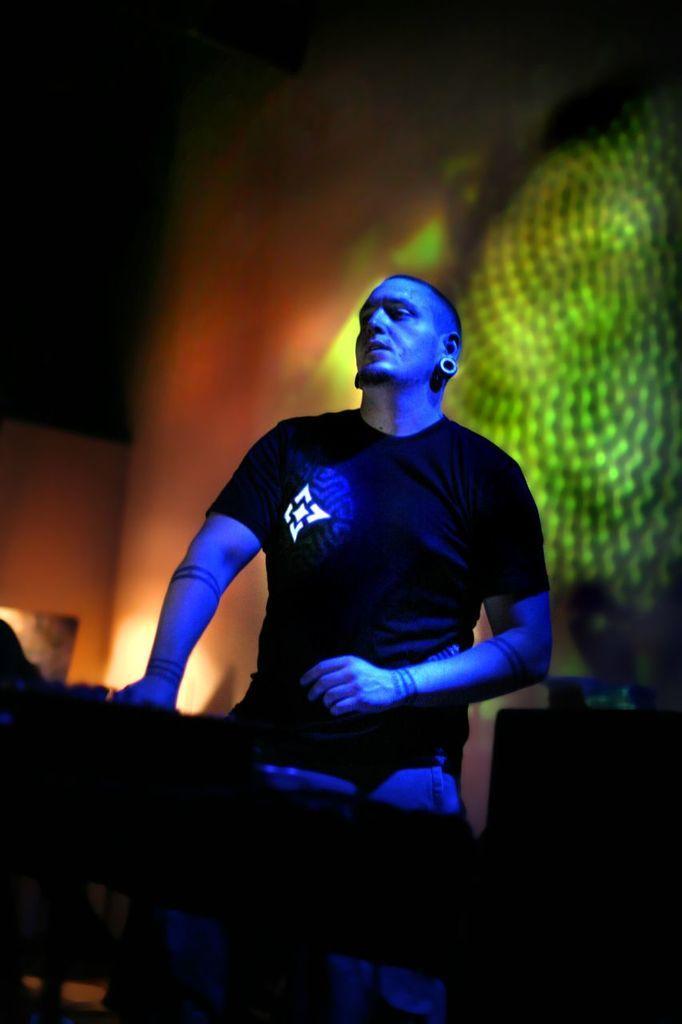How would you summarize this image in a sentence or two? In this picture I can see there is a man standing here and he is wearing a black shirt and there are lights focusing on him and on the wall in the backdrop. 